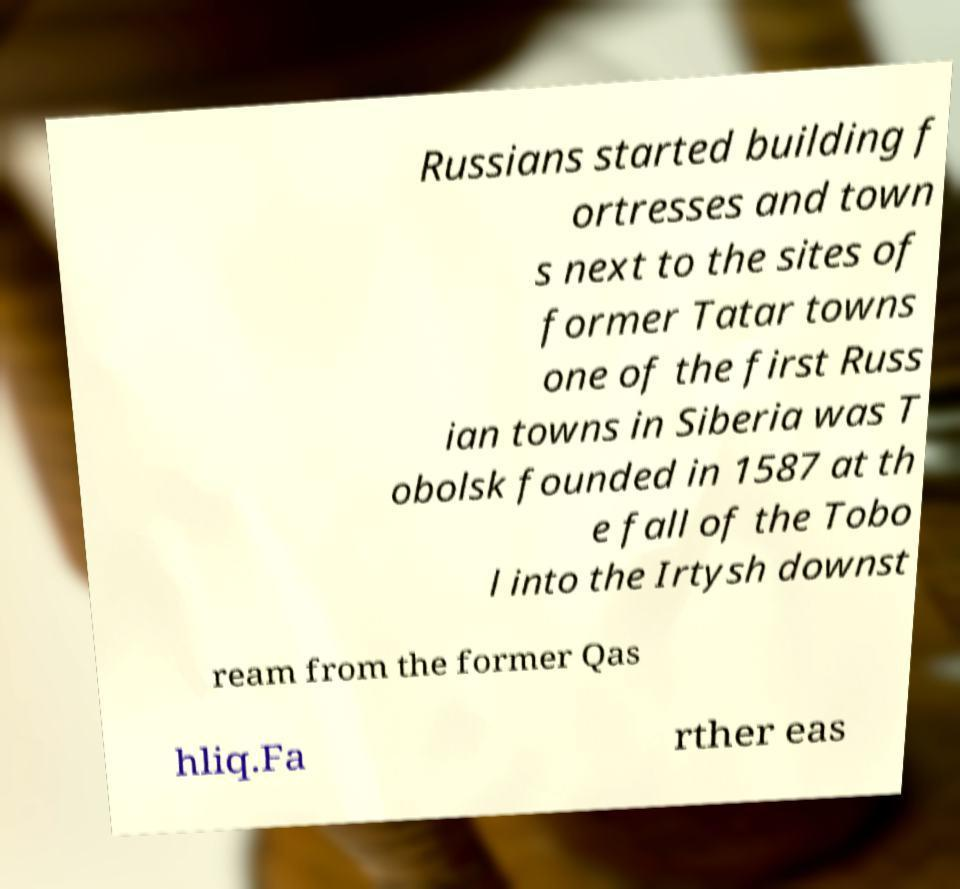What messages or text are displayed in this image? I need them in a readable, typed format. Russians started building f ortresses and town s next to the sites of former Tatar towns one of the first Russ ian towns in Siberia was T obolsk founded in 1587 at th e fall of the Tobo l into the Irtysh downst ream from the former Qas hliq.Fa rther eas 